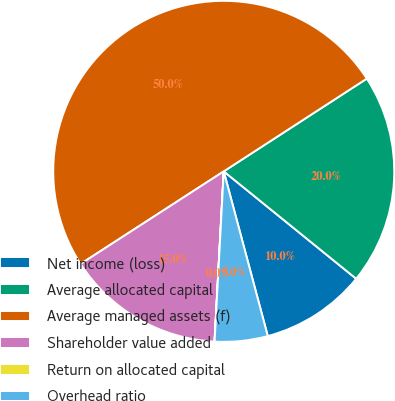<chart> <loc_0><loc_0><loc_500><loc_500><pie_chart><fcel>Net income (loss)<fcel>Average allocated capital<fcel>Average managed assets (f)<fcel>Shareholder value added<fcel>Return on allocated capital<fcel>Overhead ratio<nl><fcel>10.0%<fcel>20.0%<fcel>49.99%<fcel>15.0%<fcel>0.01%<fcel>5.01%<nl></chart> 